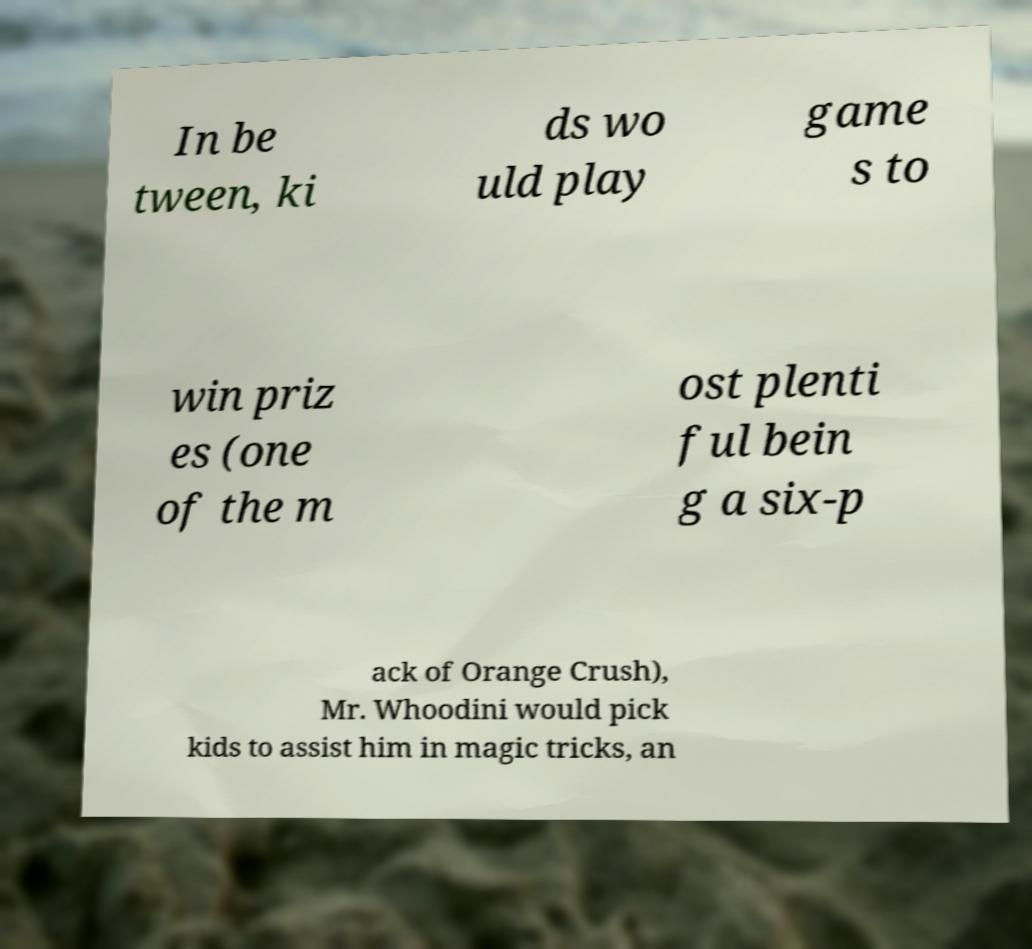Can you read and provide the text displayed in the image?This photo seems to have some interesting text. Can you extract and type it out for me? In be tween, ki ds wo uld play game s to win priz es (one of the m ost plenti ful bein g a six-p ack of Orange Crush), Mr. Whoodini would pick kids to assist him in magic tricks, an 